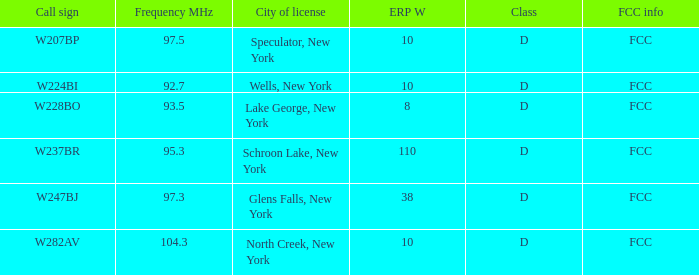Name the ERP W for frequency of 92.7 10.0. 